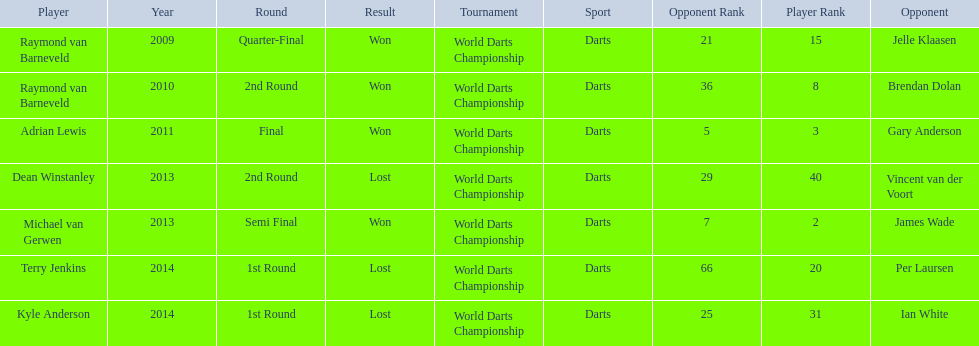Who was the last to win against his opponent? Michael van Gerwen. 